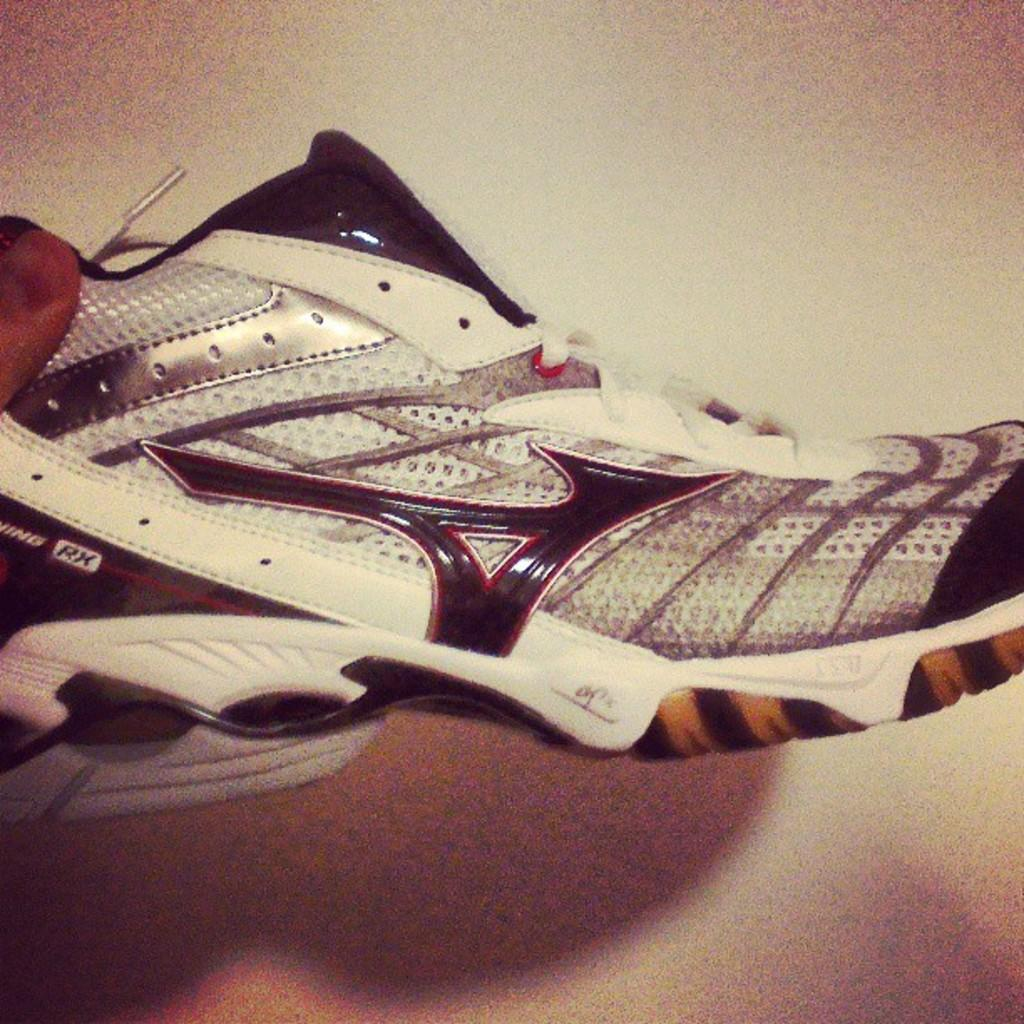What object can be seen in the image? There is a shoe in the image. What is visible in the background of the image? There is a wall in the background of the image. What type of game is being played in the image? There is no game being played in the image; it only features a shoe and a wall. How long does the shoe take to dry in the image? The image does not provide information about the shoe's condition or how long it takes to dry. 